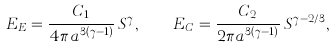Convert formula to latex. <formula><loc_0><loc_0><loc_500><loc_500>E _ { E } = \frac { C _ { 1 } } { 4 \pi a ^ { 3 ( \gamma - 1 ) } } \, S ^ { \gamma } , \quad E _ { C } = \frac { C _ { 2 } } { 2 \pi a ^ { 3 ( \gamma - 1 ) } } \, S ^ { \gamma - 2 / 3 } ,</formula> 